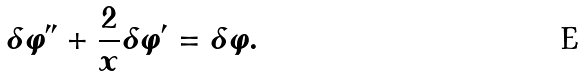<formula> <loc_0><loc_0><loc_500><loc_500>\delta \varphi ^ { \prime \prime } + \frac { 2 } { x } \delta \varphi ^ { \prime } = \delta \varphi .</formula> 